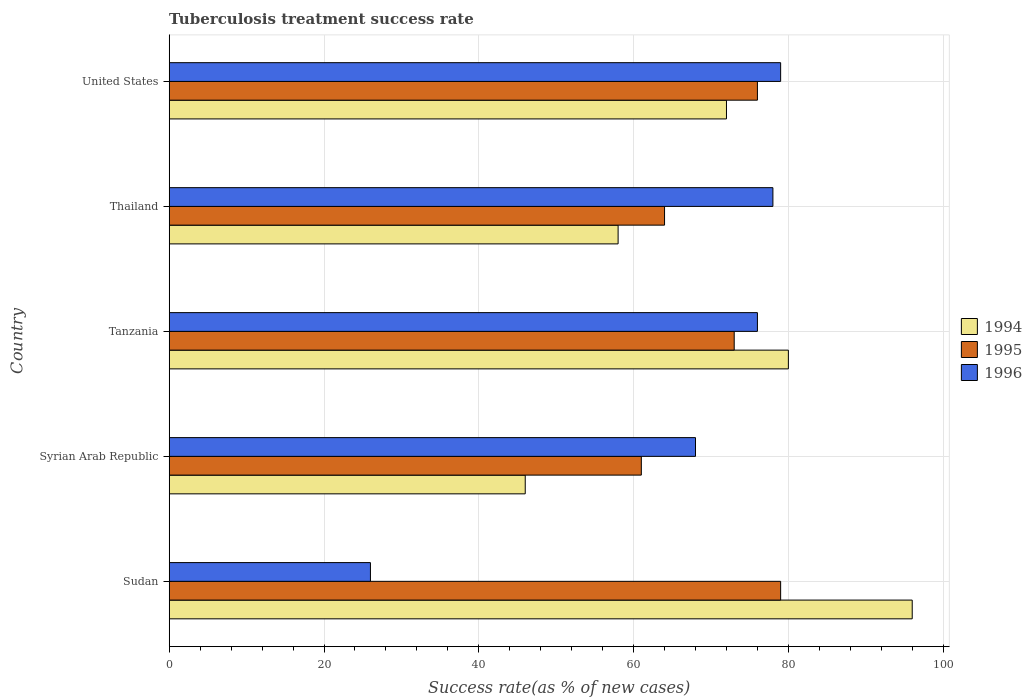Are the number of bars per tick equal to the number of legend labels?
Your response must be concise. Yes. Are the number of bars on each tick of the Y-axis equal?
Your answer should be compact. Yes. How many bars are there on the 4th tick from the top?
Your answer should be compact. 3. What is the label of the 3rd group of bars from the top?
Keep it short and to the point. Tanzania. What is the tuberculosis treatment success rate in 1996 in Syrian Arab Republic?
Keep it short and to the point. 68. Across all countries, what is the maximum tuberculosis treatment success rate in 1995?
Provide a succinct answer. 79. Across all countries, what is the minimum tuberculosis treatment success rate in 1995?
Your answer should be very brief. 61. In which country was the tuberculosis treatment success rate in 1995 minimum?
Ensure brevity in your answer.  Syrian Arab Republic. What is the total tuberculosis treatment success rate in 1995 in the graph?
Keep it short and to the point. 353. What is the difference between the tuberculosis treatment success rate in 1996 in Sudan and that in Tanzania?
Offer a very short reply. -50. What is the average tuberculosis treatment success rate in 1995 per country?
Give a very brief answer. 70.6. What is the difference between the tuberculosis treatment success rate in 1994 and tuberculosis treatment success rate in 1996 in Sudan?
Make the answer very short. 70. What is the ratio of the tuberculosis treatment success rate in 1996 in Tanzania to that in Thailand?
Ensure brevity in your answer.  0.97. Is the tuberculosis treatment success rate in 1995 in Sudan less than that in Thailand?
Your response must be concise. No. What is the difference between the highest and the second highest tuberculosis treatment success rate in 1996?
Provide a short and direct response. 1. Is the sum of the tuberculosis treatment success rate in 1996 in Syrian Arab Republic and Thailand greater than the maximum tuberculosis treatment success rate in 1995 across all countries?
Offer a very short reply. Yes. What does the 1st bar from the top in United States represents?
Provide a short and direct response. 1996. What does the 3rd bar from the bottom in Thailand represents?
Make the answer very short. 1996. Are all the bars in the graph horizontal?
Offer a very short reply. Yes. How many countries are there in the graph?
Your response must be concise. 5. Does the graph contain grids?
Your answer should be compact. Yes. What is the title of the graph?
Offer a very short reply. Tuberculosis treatment success rate. What is the label or title of the X-axis?
Ensure brevity in your answer.  Success rate(as % of new cases). What is the Success rate(as % of new cases) of 1994 in Sudan?
Your answer should be compact. 96. What is the Success rate(as % of new cases) of 1995 in Sudan?
Provide a succinct answer. 79. What is the Success rate(as % of new cases) of 1995 in Syrian Arab Republic?
Ensure brevity in your answer.  61. What is the Success rate(as % of new cases) in 1996 in Syrian Arab Republic?
Give a very brief answer. 68. What is the Success rate(as % of new cases) in 1995 in Tanzania?
Offer a very short reply. 73. What is the Success rate(as % of new cases) of 1996 in Tanzania?
Make the answer very short. 76. What is the Success rate(as % of new cases) in 1995 in Thailand?
Your answer should be compact. 64. What is the Success rate(as % of new cases) in 1995 in United States?
Ensure brevity in your answer.  76. What is the Success rate(as % of new cases) of 1996 in United States?
Give a very brief answer. 79. Across all countries, what is the maximum Success rate(as % of new cases) in 1994?
Provide a short and direct response. 96. Across all countries, what is the maximum Success rate(as % of new cases) of 1995?
Keep it short and to the point. 79. Across all countries, what is the maximum Success rate(as % of new cases) of 1996?
Your answer should be compact. 79. Across all countries, what is the minimum Success rate(as % of new cases) of 1994?
Your answer should be very brief. 46. Across all countries, what is the minimum Success rate(as % of new cases) of 1995?
Ensure brevity in your answer.  61. What is the total Success rate(as % of new cases) of 1994 in the graph?
Your response must be concise. 352. What is the total Success rate(as % of new cases) of 1995 in the graph?
Your answer should be compact. 353. What is the total Success rate(as % of new cases) of 1996 in the graph?
Ensure brevity in your answer.  327. What is the difference between the Success rate(as % of new cases) of 1994 in Sudan and that in Syrian Arab Republic?
Provide a short and direct response. 50. What is the difference between the Success rate(as % of new cases) of 1995 in Sudan and that in Syrian Arab Republic?
Your response must be concise. 18. What is the difference between the Success rate(as % of new cases) of 1996 in Sudan and that in Syrian Arab Republic?
Make the answer very short. -42. What is the difference between the Success rate(as % of new cases) of 1994 in Sudan and that in Tanzania?
Provide a short and direct response. 16. What is the difference between the Success rate(as % of new cases) of 1995 in Sudan and that in Thailand?
Provide a short and direct response. 15. What is the difference between the Success rate(as % of new cases) in 1996 in Sudan and that in Thailand?
Offer a very short reply. -52. What is the difference between the Success rate(as % of new cases) in 1995 in Sudan and that in United States?
Keep it short and to the point. 3. What is the difference between the Success rate(as % of new cases) in 1996 in Sudan and that in United States?
Keep it short and to the point. -53. What is the difference between the Success rate(as % of new cases) of 1994 in Syrian Arab Republic and that in Tanzania?
Provide a succinct answer. -34. What is the difference between the Success rate(as % of new cases) of 1995 in Syrian Arab Republic and that in Tanzania?
Your answer should be compact. -12. What is the difference between the Success rate(as % of new cases) in 1996 in Syrian Arab Republic and that in Tanzania?
Your response must be concise. -8. What is the difference between the Success rate(as % of new cases) in 1994 in Syrian Arab Republic and that in Thailand?
Provide a succinct answer. -12. What is the difference between the Success rate(as % of new cases) of 1996 in Syrian Arab Republic and that in Thailand?
Keep it short and to the point. -10. What is the difference between the Success rate(as % of new cases) of 1994 in Syrian Arab Republic and that in United States?
Provide a short and direct response. -26. What is the difference between the Success rate(as % of new cases) of 1995 in Syrian Arab Republic and that in United States?
Ensure brevity in your answer.  -15. What is the difference between the Success rate(as % of new cases) in 1996 in Syrian Arab Republic and that in United States?
Provide a short and direct response. -11. What is the difference between the Success rate(as % of new cases) in 1994 in Tanzania and that in Thailand?
Your answer should be compact. 22. What is the difference between the Success rate(as % of new cases) in 1994 in Tanzania and that in United States?
Keep it short and to the point. 8. What is the difference between the Success rate(as % of new cases) of 1995 in Tanzania and that in United States?
Keep it short and to the point. -3. What is the difference between the Success rate(as % of new cases) in 1996 in Tanzania and that in United States?
Provide a succinct answer. -3. What is the difference between the Success rate(as % of new cases) in 1994 in Thailand and that in United States?
Make the answer very short. -14. What is the difference between the Success rate(as % of new cases) of 1995 in Thailand and that in United States?
Your response must be concise. -12. What is the difference between the Success rate(as % of new cases) of 1994 in Sudan and the Success rate(as % of new cases) of 1995 in Tanzania?
Give a very brief answer. 23. What is the difference between the Success rate(as % of new cases) of 1995 in Sudan and the Success rate(as % of new cases) of 1996 in Tanzania?
Your response must be concise. 3. What is the difference between the Success rate(as % of new cases) in 1994 in Sudan and the Success rate(as % of new cases) in 1995 in Thailand?
Keep it short and to the point. 32. What is the difference between the Success rate(as % of new cases) of 1994 in Sudan and the Success rate(as % of new cases) of 1996 in Thailand?
Make the answer very short. 18. What is the difference between the Success rate(as % of new cases) in 1995 in Sudan and the Success rate(as % of new cases) in 1996 in Thailand?
Your answer should be compact. 1. What is the difference between the Success rate(as % of new cases) of 1994 in Sudan and the Success rate(as % of new cases) of 1995 in United States?
Ensure brevity in your answer.  20. What is the difference between the Success rate(as % of new cases) in 1995 in Sudan and the Success rate(as % of new cases) in 1996 in United States?
Your response must be concise. 0. What is the difference between the Success rate(as % of new cases) of 1995 in Syrian Arab Republic and the Success rate(as % of new cases) of 1996 in Tanzania?
Make the answer very short. -15. What is the difference between the Success rate(as % of new cases) of 1994 in Syrian Arab Republic and the Success rate(as % of new cases) of 1995 in Thailand?
Keep it short and to the point. -18. What is the difference between the Success rate(as % of new cases) of 1994 in Syrian Arab Republic and the Success rate(as % of new cases) of 1996 in Thailand?
Provide a succinct answer. -32. What is the difference between the Success rate(as % of new cases) of 1994 in Syrian Arab Republic and the Success rate(as % of new cases) of 1996 in United States?
Your answer should be very brief. -33. What is the difference between the Success rate(as % of new cases) of 1994 in Tanzania and the Success rate(as % of new cases) of 1995 in Thailand?
Your answer should be compact. 16. What is the difference between the Success rate(as % of new cases) of 1994 in Tanzania and the Success rate(as % of new cases) of 1996 in Thailand?
Give a very brief answer. 2. What is the difference between the Success rate(as % of new cases) of 1995 in Tanzania and the Success rate(as % of new cases) of 1996 in Thailand?
Your response must be concise. -5. What is the difference between the Success rate(as % of new cases) in 1994 in Tanzania and the Success rate(as % of new cases) in 1995 in United States?
Your answer should be compact. 4. What is the difference between the Success rate(as % of new cases) in 1994 in Thailand and the Success rate(as % of new cases) in 1995 in United States?
Give a very brief answer. -18. What is the difference between the Success rate(as % of new cases) of 1995 in Thailand and the Success rate(as % of new cases) of 1996 in United States?
Make the answer very short. -15. What is the average Success rate(as % of new cases) in 1994 per country?
Offer a very short reply. 70.4. What is the average Success rate(as % of new cases) in 1995 per country?
Your response must be concise. 70.6. What is the average Success rate(as % of new cases) of 1996 per country?
Offer a terse response. 65.4. What is the difference between the Success rate(as % of new cases) in 1994 and Success rate(as % of new cases) in 1996 in Sudan?
Ensure brevity in your answer.  70. What is the difference between the Success rate(as % of new cases) in 1994 and Success rate(as % of new cases) in 1996 in Tanzania?
Offer a terse response. 4. What is the difference between the Success rate(as % of new cases) of 1995 and Success rate(as % of new cases) of 1996 in Tanzania?
Keep it short and to the point. -3. What is the difference between the Success rate(as % of new cases) of 1995 and Success rate(as % of new cases) of 1996 in Thailand?
Your answer should be very brief. -14. What is the difference between the Success rate(as % of new cases) of 1994 and Success rate(as % of new cases) of 1996 in United States?
Make the answer very short. -7. What is the ratio of the Success rate(as % of new cases) of 1994 in Sudan to that in Syrian Arab Republic?
Provide a succinct answer. 2.09. What is the ratio of the Success rate(as % of new cases) in 1995 in Sudan to that in Syrian Arab Republic?
Ensure brevity in your answer.  1.3. What is the ratio of the Success rate(as % of new cases) in 1996 in Sudan to that in Syrian Arab Republic?
Offer a terse response. 0.38. What is the ratio of the Success rate(as % of new cases) of 1995 in Sudan to that in Tanzania?
Provide a succinct answer. 1.08. What is the ratio of the Success rate(as % of new cases) in 1996 in Sudan to that in Tanzania?
Offer a terse response. 0.34. What is the ratio of the Success rate(as % of new cases) of 1994 in Sudan to that in Thailand?
Give a very brief answer. 1.66. What is the ratio of the Success rate(as % of new cases) in 1995 in Sudan to that in Thailand?
Provide a succinct answer. 1.23. What is the ratio of the Success rate(as % of new cases) of 1996 in Sudan to that in Thailand?
Offer a terse response. 0.33. What is the ratio of the Success rate(as % of new cases) in 1995 in Sudan to that in United States?
Make the answer very short. 1.04. What is the ratio of the Success rate(as % of new cases) in 1996 in Sudan to that in United States?
Your response must be concise. 0.33. What is the ratio of the Success rate(as % of new cases) in 1994 in Syrian Arab Republic to that in Tanzania?
Ensure brevity in your answer.  0.57. What is the ratio of the Success rate(as % of new cases) in 1995 in Syrian Arab Republic to that in Tanzania?
Make the answer very short. 0.84. What is the ratio of the Success rate(as % of new cases) of 1996 in Syrian Arab Republic to that in Tanzania?
Your answer should be compact. 0.89. What is the ratio of the Success rate(as % of new cases) of 1994 in Syrian Arab Republic to that in Thailand?
Provide a succinct answer. 0.79. What is the ratio of the Success rate(as % of new cases) of 1995 in Syrian Arab Republic to that in Thailand?
Offer a terse response. 0.95. What is the ratio of the Success rate(as % of new cases) of 1996 in Syrian Arab Republic to that in Thailand?
Provide a succinct answer. 0.87. What is the ratio of the Success rate(as % of new cases) in 1994 in Syrian Arab Republic to that in United States?
Offer a very short reply. 0.64. What is the ratio of the Success rate(as % of new cases) of 1995 in Syrian Arab Republic to that in United States?
Your answer should be compact. 0.8. What is the ratio of the Success rate(as % of new cases) in 1996 in Syrian Arab Republic to that in United States?
Offer a very short reply. 0.86. What is the ratio of the Success rate(as % of new cases) of 1994 in Tanzania to that in Thailand?
Provide a short and direct response. 1.38. What is the ratio of the Success rate(as % of new cases) in 1995 in Tanzania to that in Thailand?
Your response must be concise. 1.14. What is the ratio of the Success rate(as % of new cases) of 1996 in Tanzania to that in Thailand?
Offer a terse response. 0.97. What is the ratio of the Success rate(as % of new cases) of 1995 in Tanzania to that in United States?
Your response must be concise. 0.96. What is the ratio of the Success rate(as % of new cases) in 1994 in Thailand to that in United States?
Make the answer very short. 0.81. What is the ratio of the Success rate(as % of new cases) of 1995 in Thailand to that in United States?
Ensure brevity in your answer.  0.84. What is the ratio of the Success rate(as % of new cases) of 1996 in Thailand to that in United States?
Give a very brief answer. 0.99. What is the difference between the highest and the second highest Success rate(as % of new cases) of 1995?
Keep it short and to the point. 3. What is the difference between the highest and the lowest Success rate(as % of new cases) of 1995?
Provide a succinct answer. 18. 